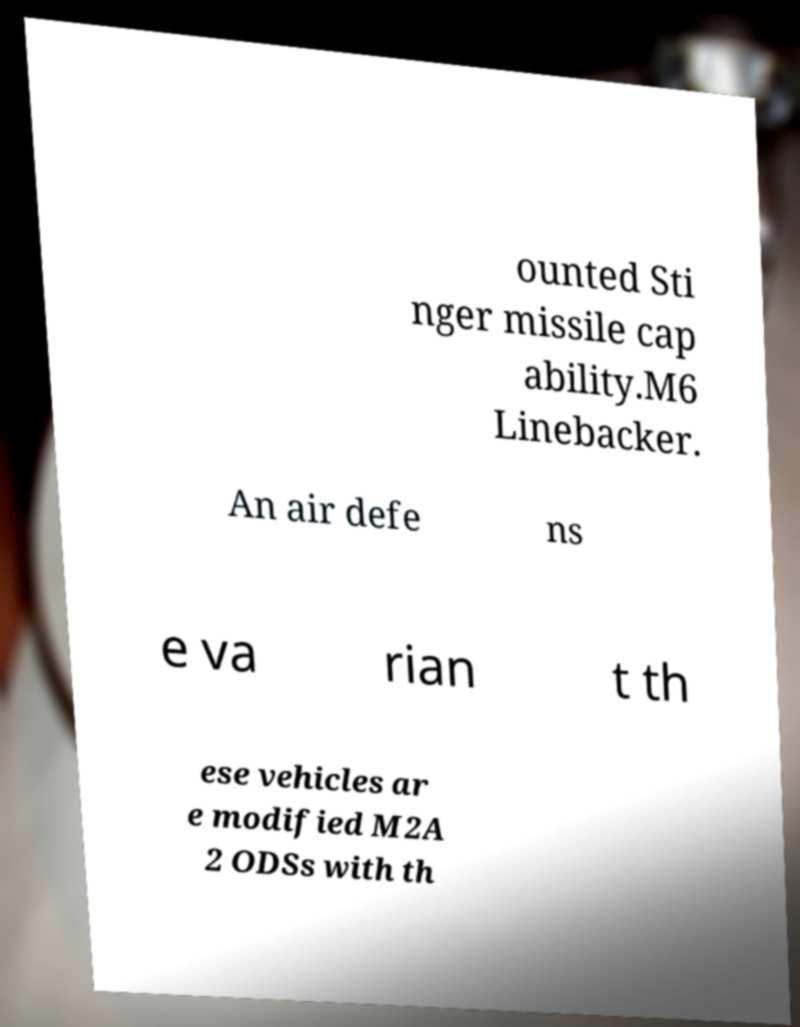For documentation purposes, I need the text within this image transcribed. Could you provide that? ounted Sti nger missile cap ability.M6 Linebacker. An air defe ns e va rian t th ese vehicles ar e modified M2A 2 ODSs with th 